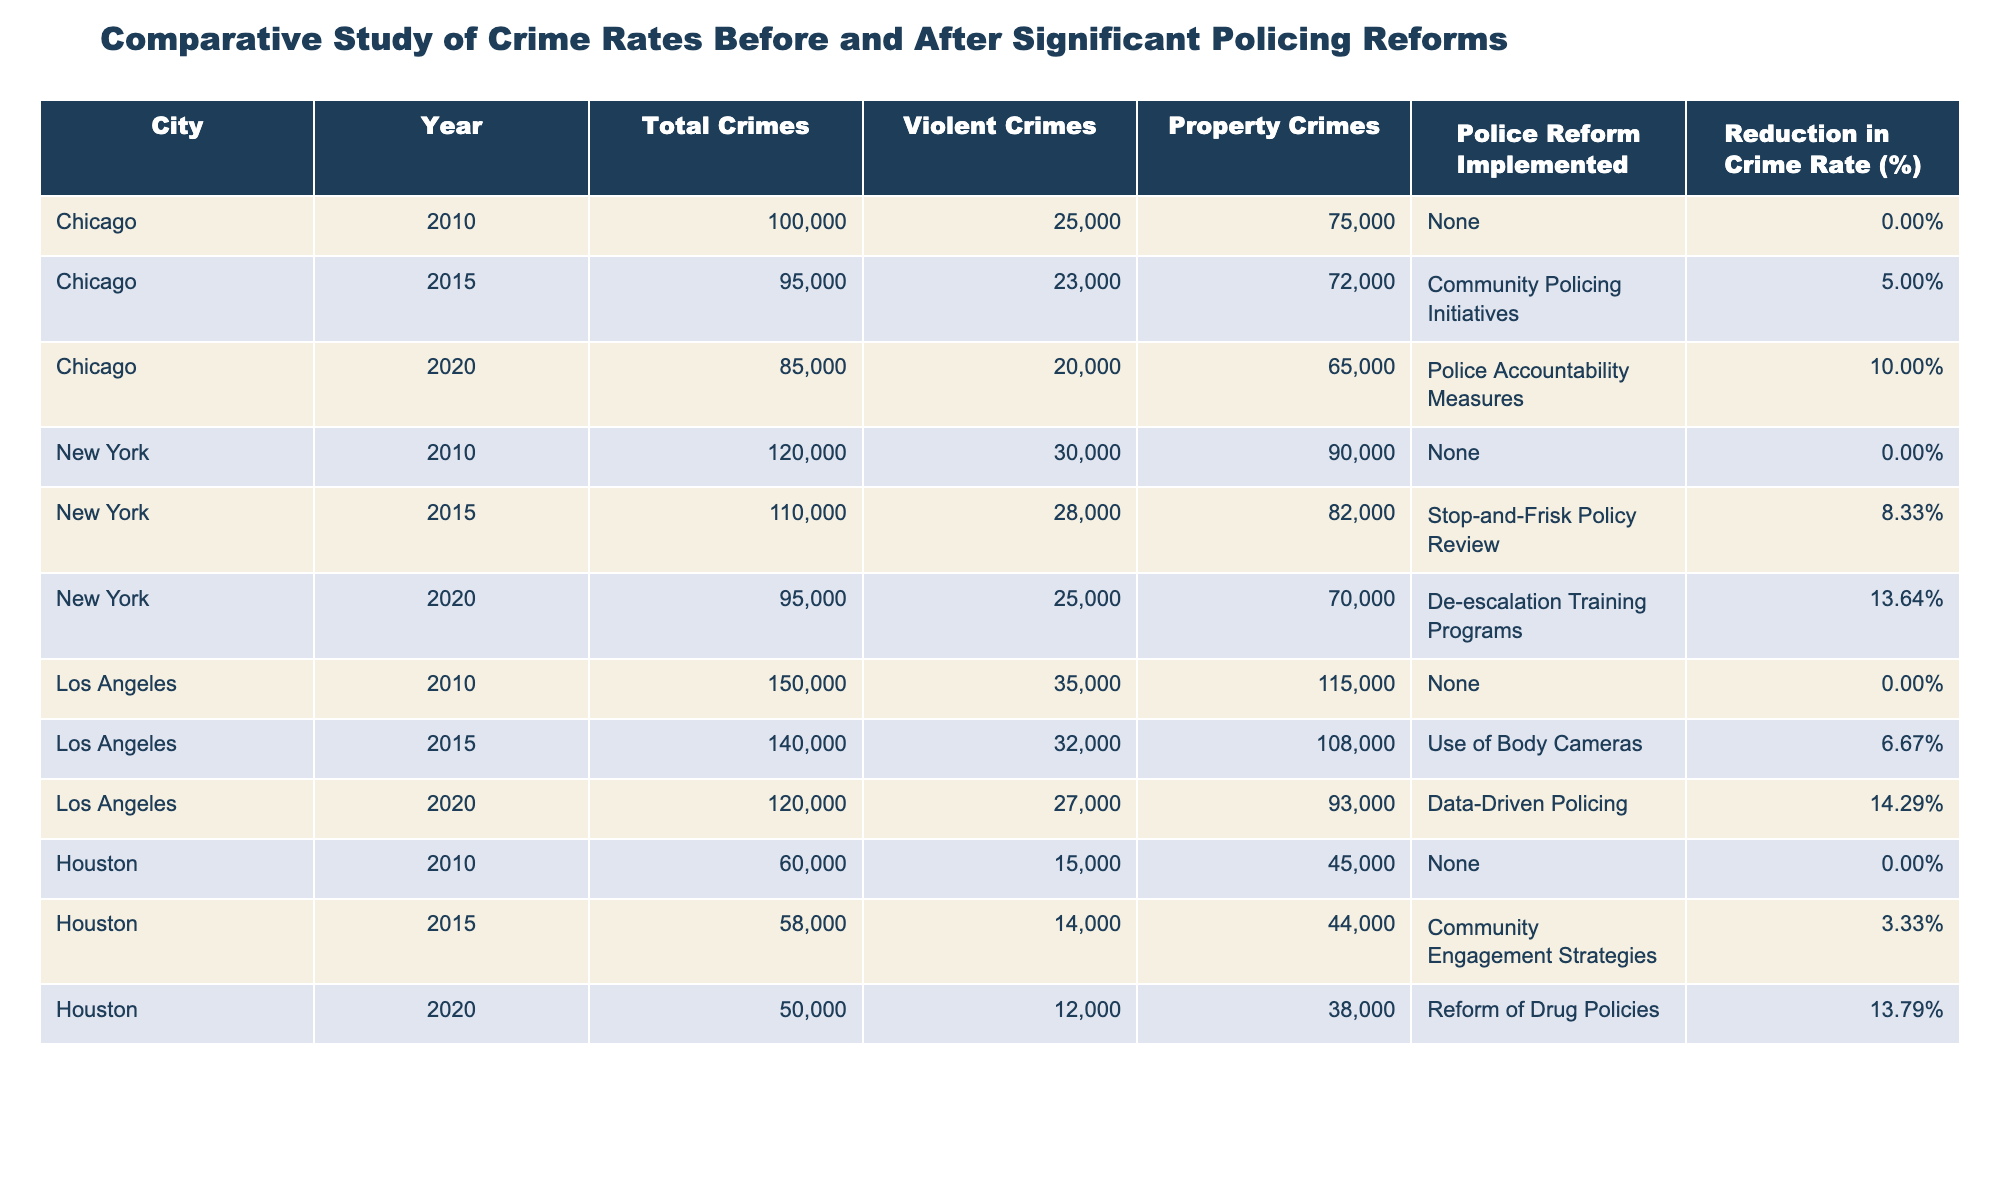What was the total crime count in Los Angeles in 2015? In the table, I look for the row corresponding to Los Angeles and the year 2015. The value for total crimes in that row is 140,000.
Answer: 140,000 Which city had the highest reduction in crime rate from 2010 to 2020? I compare the reduction in crime rate percentages between 2010 and 2020 for each city. Chicago reduced by 10%, New York reduced by 13.64%, Los Angeles by 14.29%, and Houston by 13.79%. Los Angeles had the highest reduction.
Answer: Los Angeles True or False: New York implemented policing reforms only between 2010 and 2020. I verify the years listed in the table for New York. The two reforms in the table are noted in 2015 and 2020, thus indicating that reforms were indeed implemented only during those years.
Answer: True What is the average total number of crimes reported for Houston between 2010 and 2020? I sum the total crimes for Houston over the years 2010 (60,000), 2015 (58,000), and 2020 (50,000), giving a total of 168,000. Dividing by 3 (the number of years) provides an average of 56,000.
Answer: 56,000 How many violent crimes were reported in Chicago in 2020? Looking across the row for Chicago in the year 2020, the violent crimes count is 20,000.
Answer: 20,000 Which police reform in New York led to a larger reduction in crime rate, the Stop-and-Frisk Policy Review or the De-escalation Training Programs? I examine the reductions in crime rates from the table: Stop-and-Frisk had a reduction of 8.33% and De-escalation had a reduction of 13.64%. The latter had a larger impact.
Answer: De-escalation Training Programs What was the total reduction in crime rate for Los Angeles from 2010 to 2020? I look at the total reduction in crime rates listed for Los Angeles in each of the given years (0% in 2010, 6.67% in 2015, and 14.29% in 2020). The total reductions from 0 to 14.29% span a 14.29 percentage point reduction over that time.
Answer: 14.29% In which year did Houston experience the lowest total crimes? The table shows total crimes for Houston as 60,000 in 2010, 58,000 in 2015, and 50,000 in 2020. The lowest total crimes were reported in 2020.
Answer: 2020 